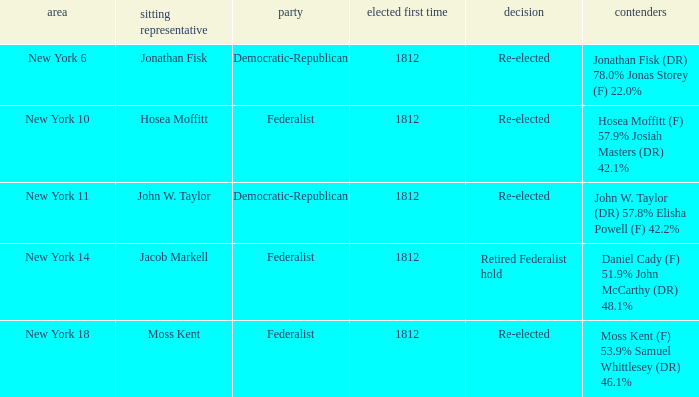Name the incumbent for new york 10 Hosea Moffitt. Give me the full table as a dictionary. {'header': ['area', 'sitting representative', 'party', 'elected first time', 'decision', 'contenders'], 'rows': [['New York 6', 'Jonathan Fisk', 'Democratic-Republican', '1812', 'Re-elected', 'Jonathan Fisk (DR) 78.0% Jonas Storey (F) 22.0%'], ['New York 10', 'Hosea Moffitt', 'Federalist', '1812', 'Re-elected', 'Hosea Moffitt (F) 57.9% Josiah Masters (DR) 42.1%'], ['New York 11', 'John W. Taylor', 'Democratic-Republican', '1812', 'Re-elected', 'John W. Taylor (DR) 57.8% Elisha Powell (F) 42.2%'], ['New York 14', 'Jacob Markell', 'Federalist', '1812', 'Retired Federalist hold', 'Daniel Cady (F) 51.9% John McCarthy (DR) 48.1%'], ['New York 18', 'Moss Kent', 'Federalist', '1812', 'Re-elected', 'Moss Kent (F) 53.9% Samuel Whittlesey (DR) 46.1%']]} 